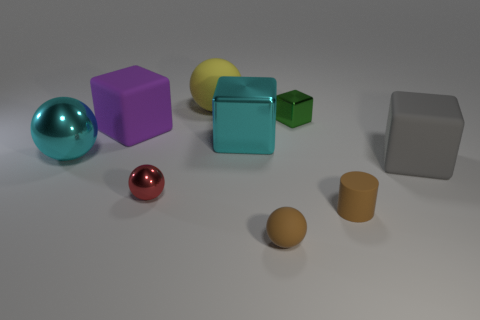Are there the same number of large balls behind the cyan metal block and tiny green cylinders?
Your response must be concise. No. Are there any other things that have the same material as the small brown cylinder?
Your response must be concise. Yes. What number of small objects are either spheres or red objects?
Give a very brief answer. 2. The matte thing that is the same color as the tiny matte ball is what shape?
Make the answer very short. Cylinder. Is the material of the cube on the left side of the red ball the same as the red sphere?
Provide a short and direct response. No. There is a sphere that is in front of the small ball that is left of the yellow sphere; what is it made of?
Give a very brief answer. Rubber. What number of big gray objects are the same shape as the large yellow object?
Ensure brevity in your answer.  0. There is a cyan object to the right of the large cyan ball in front of the rubber block on the left side of the tiny green shiny block; what is its size?
Offer a terse response. Large. What number of green objects are metal objects or big metal spheres?
Provide a short and direct response. 1. Is the shape of the tiny rubber object that is on the left side of the green block the same as  the tiny red shiny object?
Ensure brevity in your answer.  Yes. 